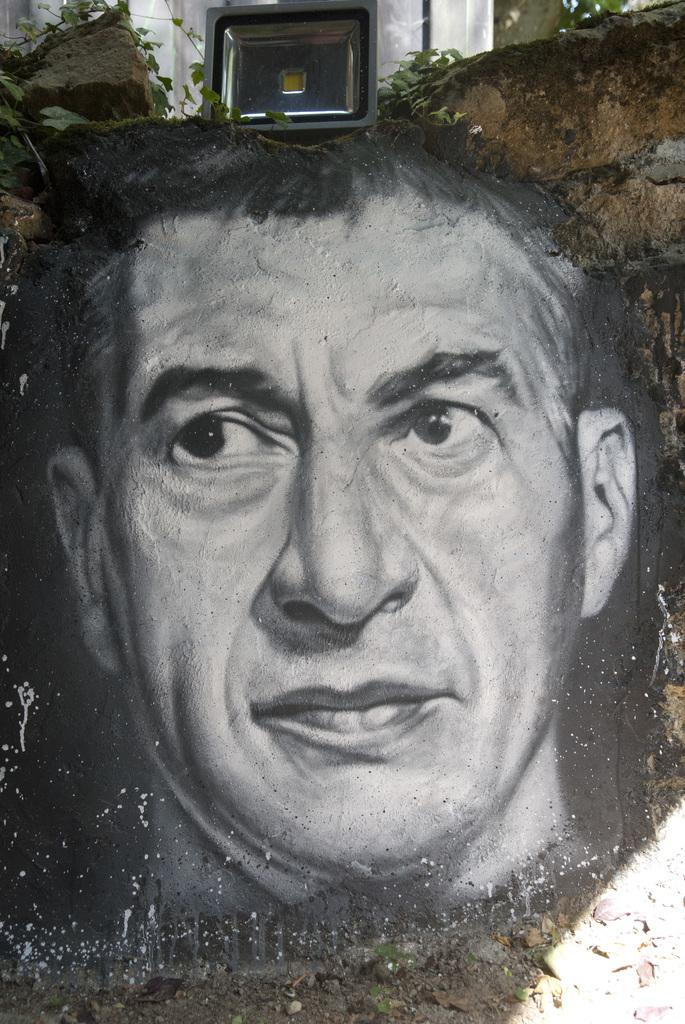What is depicted on the wall in the image? There is a painting of a person on the wall. What can be seen in the background of the image? There is an object and leaves present in the background of the image. What type of beam is holding up the ceiling in the image? There is no beam visible in the image; it only shows a painting of a person on the wall and an object with leaves in the background. 